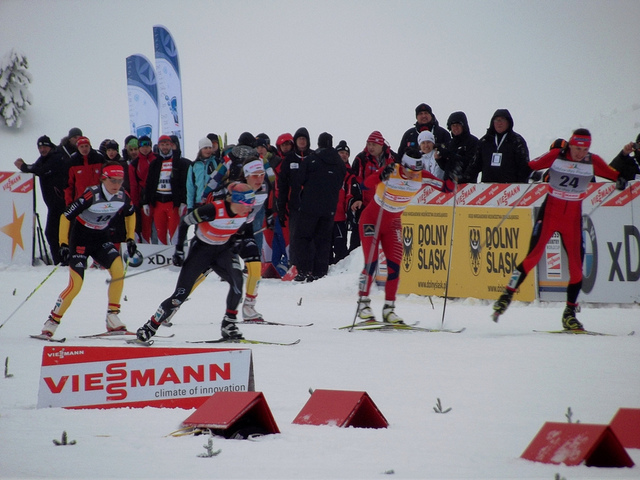How many people are there? There are seven athletes actively competing in the cross-country ski race, each intensely focused on maintaining speed and balance. Spectators and event staff can be seen in the background, but they are not included in the count. 